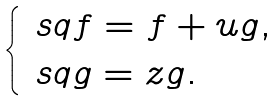Convert formula to latex. <formula><loc_0><loc_0><loc_500><loc_500>\begin{cases} \ s q f = f + u g , \\ \ s q g = z g . \end{cases}</formula> 